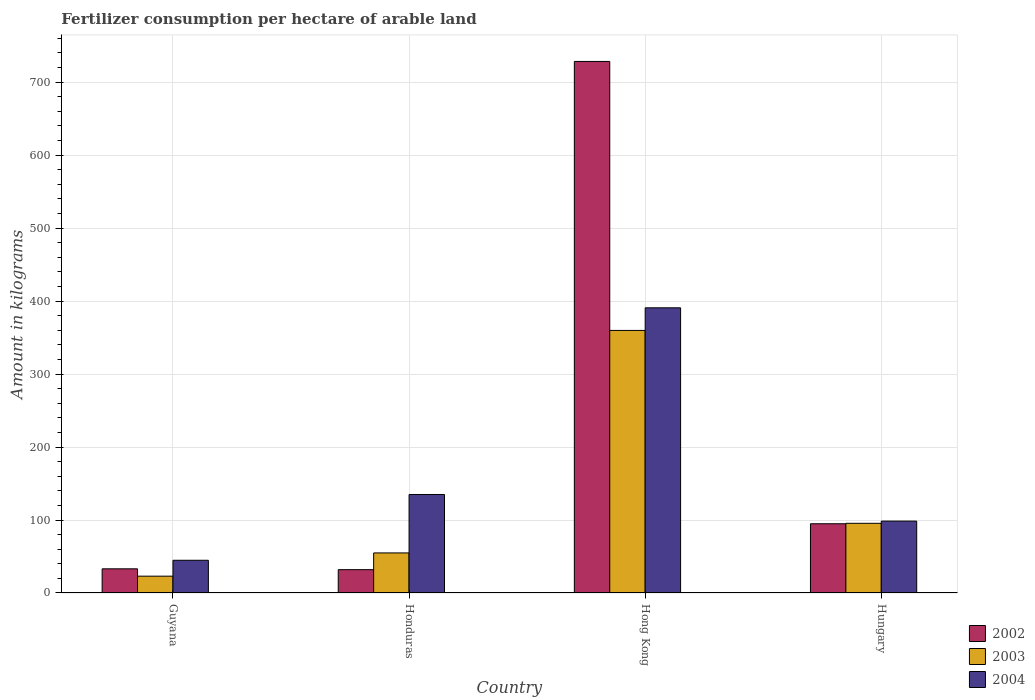How many groups of bars are there?
Offer a terse response. 4. How many bars are there on the 1st tick from the left?
Provide a short and direct response. 3. How many bars are there on the 1st tick from the right?
Your answer should be compact. 3. What is the label of the 2nd group of bars from the left?
Ensure brevity in your answer.  Honduras. What is the amount of fertilizer consumption in 2003 in Hong Kong?
Provide a short and direct response. 359.8. Across all countries, what is the maximum amount of fertilizer consumption in 2003?
Provide a short and direct response. 359.8. Across all countries, what is the minimum amount of fertilizer consumption in 2002?
Your answer should be very brief. 31.96. In which country was the amount of fertilizer consumption in 2003 maximum?
Your answer should be very brief. Hong Kong. In which country was the amount of fertilizer consumption in 2004 minimum?
Provide a short and direct response. Guyana. What is the total amount of fertilizer consumption in 2003 in the graph?
Offer a terse response. 533.25. What is the difference between the amount of fertilizer consumption in 2004 in Honduras and that in Hong Kong?
Keep it short and to the point. -255.83. What is the difference between the amount of fertilizer consumption in 2004 in Hong Kong and the amount of fertilizer consumption in 2003 in Honduras?
Make the answer very short. 335.9. What is the average amount of fertilizer consumption in 2002 per country?
Provide a short and direct response. 222.09. What is the difference between the amount of fertilizer consumption of/in 2003 and amount of fertilizer consumption of/in 2002 in Hungary?
Ensure brevity in your answer.  0.62. What is the ratio of the amount of fertilizer consumption in 2004 in Guyana to that in Hungary?
Offer a very short reply. 0.46. What is the difference between the highest and the second highest amount of fertilizer consumption in 2004?
Give a very brief answer. -36.45. What is the difference between the highest and the lowest amount of fertilizer consumption in 2003?
Keep it short and to the point. 336.74. How many bars are there?
Make the answer very short. 12. How many countries are there in the graph?
Give a very brief answer. 4. Are the values on the major ticks of Y-axis written in scientific E-notation?
Offer a terse response. No. Does the graph contain any zero values?
Provide a short and direct response. No. How many legend labels are there?
Ensure brevity in your answer.  3. How are the legend labels stacked?
Offer a very short reply. Vertical. What is the title of the graph?
Make the answer very short. Fertilizer consumption per hectare of arable land. What is the label or title of the Y-axis?
Make the answer very short. Amount in kilograms. What is the Amount in kilograms in 2002 in Guyana?
Ensure brevity in your answer.  33.11. What is the Amount in kilograms of 2003 in Guyana?
Offer a terse response. 23.06. What is the Amount in kilograms in 2004 in Guyana?
Provide a succinct answer. 44.83. What is the Amount in kilograms in 2002 in Honduras?
Your answer should be very brief. 31.96. What is the Amount in kilograms in 2003 in Honduras?
Offer a terse response. 54.9. What is the Amount in kilograms of 2004 in Honduras?
Keep it short and to the point. 134.97. What is the Amount in kilograms of 2002 in Hong Kong?
Offer a terse response. 728.4. What is the Amount in kilograms in 2003 in Hong Kong?
Provide a short and direct response. 359.8. What is the Amount in kilograms in 2004 in Hong Kong?
Offer a terse response. 390.8. What is the Amount in kilograms of 2002 in Hungary?
Make the answer very short. 94.88. What is the Amount in kilograms of 2003 in Hungary?
Provide a short and direct response. 95.5. What is the Amount in kilograms in 2004 in Hungary?
Your response must be concise. 98.52. Across all countries, what is the maximum Amount in kilograms in 2002?
Offer a very short reply. 728.4. Across all countries, what is the maximum Amount in kilograms in 2003?
Offer a very short reply. 359.8. Across all countries, what is the maximum Amount in kilograms of 2004?
Keep it short and to the point. 390.8. Across all countries, what is the minimum Amount in kilograms in 2002?
Provide a short and direct response. 31.96. Across all countries, what is the minimum Amount in kilograms of 2003?
Your answer should be very brief. 23.06. Across all countries, what is the minimum Amount in kilograms in 2004?
Give a very brief answer. 44.83. What is the total Amount in kilograms of 2002 in the graph?
Your response must be concise. 888.34. What is the total Amount in kilograms in 2003 in the graph?
Provide a succinct answer. 533.25. What is the total Amount in kilograms of 2004 in the graph?
Your answer should be very brief. 669.12. What is the difference between the Amount in kilograms of 2002 in Guyana and that in Honduras?
Offer a terse response. 1.15. What is the difference between the Amount in kilograms in 2003 in Guyana and that in Honduras?
Ensure brevity in your answer.  -31.84. What is the difference between the Amount in kilograms in 2004 in Guyana and that in Honduras?
Your answer should be compact. -90.13. What is the difference between the Amount in kilograms in 2002 in Guyana and that in Hong Kong?
Keep it short and to the point. -695.29. What is the difference between the Amount in kilograms in 2003 in Guyana and that in Hong Kong?
Offer a very short reply. -336.74. What is the difference between the Amount in kilograms of 2004 in Guyana and that in Hong Kong?
Give a very brief answer. -345.97. What is the difference between the Amount in kilograms of 2002 in Guyana and that in Hungary?
Provide a short and direct response. -61.77. What is the difference between the Amount in kilograms of 2003 in Guyana and that in Hungary?
Ensure brevity in your answer.  -72.44. What is the difference between the Amount in kilograms of 2004 in Guyana and that in Hungary?
Offer a terse response. -53.69. What is the difference between the Amount in kilograms of 2002 in Honduras and that in Hong Kong?
Ensure brevity in your answer.  -696.44. What is the difference between the Amount in kilograms of 2003 in Honduras and that in Hong Kong?
Offer a very short reply. -304.9. What is the difference between the Amount in kilograms in 2004 in Honduras and that in Hong Kong?
Keep it short and to the point. -255.83. What is the difference between the Amount in kilograms in 2002 in Honduras and that in Hungary?
Ensure brevity in your answer.  -62.92. What is the difference between the Amount in kilograms in 2003 in Honduras and that in Hungary?
Give a very brief answer. -40.6. What is the difference between the Amount in kilograms of 2004 in Honduras and that in Hungary?
Your answer should be very brief. 36.45. What is the difference between the Amount in kilograms of 2002 in Hong Kong and that in Hungary?
Offer a very short reply. 633.52. What is the difference between the Amount in kilograms of 2003 in Hong Kong and that in Hungary?
Keep it short and to the point. 264.3. What is the difference between the Amount in kilograms in 2004 in Hong Kong and that in Hungary?
Keep it short and to the point. 292.28. What is the difference between the Amount in kilograms in 2002 in Guyana and the Amount in kilograms in 2003 in Honduras?
Provide a succinct answer. -21.79. What is the difference between the Amount in kilograms of 2002 in Guyana and the Amount in kilograms of 2004 in Honduras?
Your response must be concise. -101.86. What is the difference between the Amount in kilograms of 2003 in Guyana and the Amount in kilograms of 2004 in Honduras?
Ensure brevity in your answer.  -111.91. What is the difference between the Amount in kilograms of 2002 in Guyana and the Amount in kilograms of 2003 in Hong Kong?
Ensure brevity in your answer.  -326.69. What is the difference between the Amount in kilograms in 2002 in Guyana and the Amount in kilograms in 2004 in Hong Kong?
Provide a succinct answer. -357.69. What is the difference between the Amount in kilograms in 2003 in Guyana and the Amount in kilograms in 2004 in Hong Kong?
Your answer should be very brief. -367.74. What is the difference between the Amount in kilograms of 2002 in Guyana and the Amount in kilograms of 2003 in Hungary?
Your answer should be compact. -62.39. What is the difference between the Amount in kilograms in 2002 in Guyana and the Amount in kilograms in 2004 in Hungary?
Provide a short and direct response. -65.41. What is the difference between the Amount in kilograms of 2003 in Guyana and the Amount in kilograms of 2004 in Hungary?
Your response must be concise. -75.47. What is the difference between the Amount in kilograms of 2002 in Honduras and the Amount in kilograms of 2003 in Hong Kong?
Make the answer very short. -327.84. What is the difference between the Amount in kilograms of 2002 in Honduras and the Amount in kilograms of 2004 in Hong Kong?
Your answer should be very brief. -358.84. What is the difference between the Amount in kilograms in 2003 in Honduras and the Amount in kilograms in 2004 in Hong Kong?
Keep it short and to the point. -335.9. What is the difference between the Amount in kilograms of 2002 in Honduras and the Amount in kilograms of 2003 in Hungary?
Provide a succinct answer. -63.54. What is the difference between the Amount in kilograms in 2002 in Honduras and the Amount in kilograms in 2004 in Hungary?
Provide a short and direct response. -66.56. What is the difference between the Amount in kilograms in 2003 in Honduras and the Amount in kilograms in 2004 in Hungary?
Your response must be concise. -43.62. What is the difference between the Amount in kilograms in 2002 in Hong Kong and the Amount in kilograms in 2003 in Hungary?
Keep it short and to the point. 632.9. What is the difference between the Amount in kilograms in 2002 in Hong Kong and the Amount in kilograms in 2004 in Hungary?
Your answer should be compact. 629.88. What is the difference between the Amount in kilograms in 2003 in Hong Kong and the Amount in kilograms in 2004 in Hungary?
Your answer should be very brief. 261.28. What is the average Amount in kilograms of 2002 per country?
Keep it short and to the point. 222.09. What is the average Amount in kilograms in 2003 per country?
Keep it short and to the point. 133.31. What is the average Amount in kilograms of 2004 per country?
Ensure brevity in your answer.  167.28. What is the difference between the Amount in kilograms in 2002 and Amount in kilograms in 2003 in Guyana?
Your answer should be compact. 10.06. What is the difference between the Amount in kilograms in 2002 and Amount in kilograms in 2004 in Guyana?
Ensure brevity in your answer.  -11.72. What is the difference between the Amount in kilograms in 2003 and Amount in kilograms in 2004 in Guyana?
Offer a terse response. -21.78. What is the difference between the Amount in kilograms in 2002 and Amount in kilograms in 2003 in Honduras?
Keep it short and to the point. -22.94. What is the difference between the Amount in kilograms in 2002 and Amount in kilograms in 2004 in Honduras?
Your response must be concise. -103.01. What is the difference between the Amount in kilograms of 2003 and Amount in kilograms of 2004 in Honduras?
Make the answer very short. -80.07. What is the difference between the Amount in kilograms in 2002 and Amount in kilograms in 2003 in Hong Kong?
Your answer should be compact. 368.6. What is the difference between the Amount in kilograms in 2002 and Amount in kilograms in 2004 in Hong Kong?
Make the answer very short. 337.6. What is the difference between the Amount in kilograms in 2003 and Amount in kilograms in 2004 in Hong Kong?
Make the answer very short. -31. What is the difference between the Amount in kilograms of 2002 and Amount in kilograms of 2003 in Hungary?
Your response must be concise. -0.62. What is the difference between the Amount in kilograms of 2002 and Amount in kilograms of 2004 in Hungary?
Offer a terse response. -3.64. What is the difference between the Amount in kilograms in 2003 and Amount in kilograms in 2004 in Hungary?
Offer a very short reply. -3.02. What is the ratio of the Amount in kilograms in 2002 in Guyana to that in Honduras?
Make the answer very short. 1.04. What is the ratio of the Amount in kilograms of 2003 in Guyana to that in Honduras?
Your answer should be compact. 0.42. What is the ratio of the Amount in kilograms in 2004 in Guyana to that in Honduras?
Offer a very short reply. 0.33. What is the ratio of the Amount in kilograms in 2002 in Guyana to that in Hong Kong?
Your answer should be very brief. 0.05. What is the ratio of the Amount in kilograms of 2003 in Guyana to that in Hong Kong?
Provide a short and direct response. 0.06. What is the ratio of the Amount in kilograms of 2004 in Guyana to that in Hong Kong?
Give a very brief answer. 0.11. What is the ratio of the Amount in kilograms in 2002 in Guyana to that in Hungary?
Provide a short and direct response. 0.35. What is the ratio of the Amount in kilograms in 2003 in Guyana to that in Hungary?
Your answer should be very brief. 0.24. What is the ratio of the Amount in kilograms of 2004 in Guyana to that in Hungary?
Make the answer very short. 0.46. What is the ratio of the Amount in kilograms of 2002 in Honduras to that in Hong Kong?
Provide a short and direct response. 0.04. What is the ratio of the Amount in kilograms in 2003 in Honduras to that in Hong Kong?
Offer a very short reply. 0.15. What is the ratio of the Amount in kilograms in 2004 in Honduras to that in Hong Kong?
Your answer should be compact. 0.35. What is the ratio of the Amount in kilograms of 2002 in Honduras to that in Hungary?
Ensure brevity in your answer.  0.34. What is the ratio of the Amount in kilograms of 2003 in Honduras to that in Hungary?
Give a very brief answer. 0.57. What is the ratio of the Amount in kilograms of 2004 in Honduras to that in Hungary?
Keep it short and to the point. 1.37. What is the ratio of the Amount in kilograms in 2002 in Hong Kong to that in Hungary?
Offer a terse response. 7.68. What is the ratio of the Amount in kilograms of 2003 in Hong Kong to that in Hungary?
Provide a short and direct response. 3.77. What is the ratio of the Amount in kilograms in 2004 in Hong Kong to that in Hungary?
Your answer should be very brief. 3.97. What is the difference between the highest and the second highest Amount in kilograms in 2002?
Give a very brief answer. 633.52. What is the difference between the highest and the second highest Amount in kilograms of 2003?
Keep it short and to the point. 264.3. What is the difference between the highest and the second highest Amount in kilograms of 2004?
Provide a succinct answer. 255.83. What is the difference between the highest and the lowest Amount in kilograms in 2002?
Provide a short and direct response. 696.44. What is the difference between the highest and the lowest Amount in kilograms in 2003?
Offer a very short reply. 336.74. What is the difference between the highest and the lowest Amount in kilograms of 2004?
Make the answer very short. 345.97. 